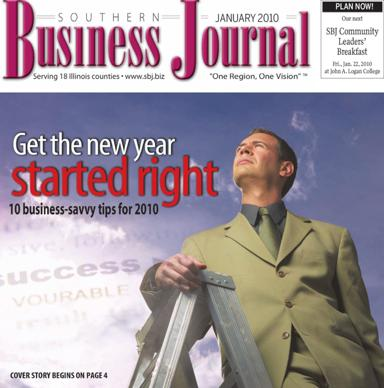In which publication can I find the 10 business savvy tips for 2010? The 10 invaluable business savvy tips for 2010 are featured in the Southern Business Journal, infamously referred to as SBJ. This compelling cover story begins on page 4 of the January 2010 issue, offering expert advice on how to harness success and navigate the challenges of the new year. 